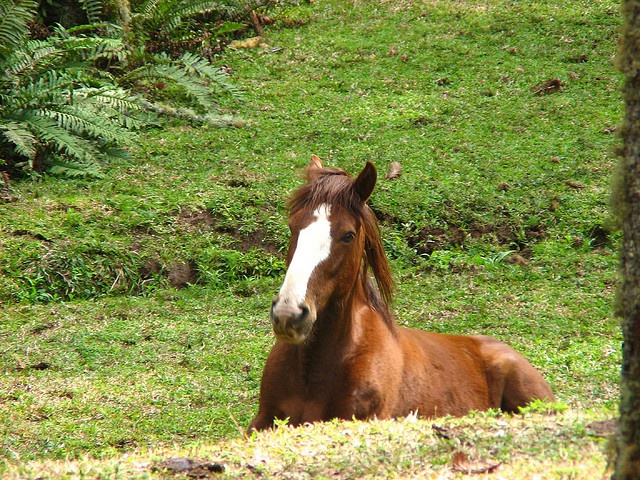Describe the objects in this image and their specific colors. I can see a horse in darkgreen, maroon, black, brown, and tan tones in this image. 